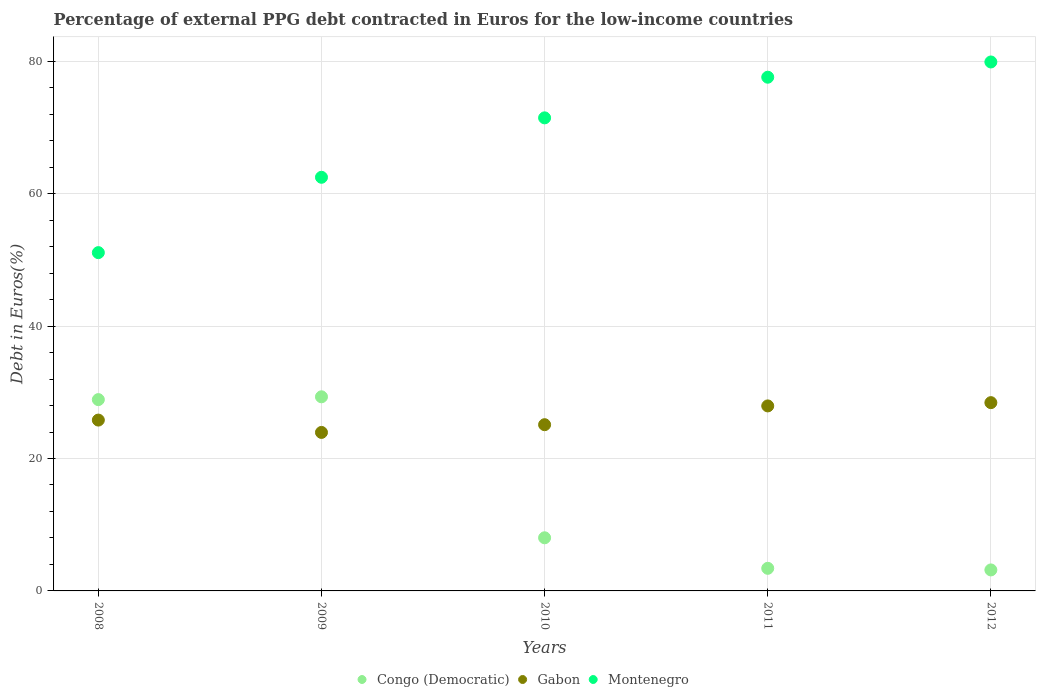Is the number of dotlines equal to the number of legend labels?
Give a very brief answer. Yes. What is the percentage of external PPG debt contracted in Euros in Montenegro in 2008?
Your answer should be very brief. 51.09. Across all years, what is the maximum percentage of external PPG debt contracted in Euros in Gabon?
Offer a very short reply. 28.43. Across all years, what is the minimum percentage of external PPG debt contracted in Euros in Montenegro?
Your answer should be compact. 51.09. In which year was the percentage of external PPG debt contracted in Euros in Montenegro maximum?
Offer a very short reply. 2012. In which year was the percentage of external PPG debt contracted in Euros in Gabon minimum?
Make the answer very short. 2009. What is the total percentage of external PPG debt contracted in Euros in Congo (Democratic) in the graph?
Keep it short and to the point. 72.82. What is the difference between the percentage of external PPG debt contracted in Euros in Gabon in 2008 and that in 2010?
Make the answer very short. 0.7. What is the difference between the percentage of external PPG debt contracted in Euros in Congo (Democratic) in 2009 and the percentage of external PPG debt contracted in Euros in Gabon in 2012?
Keep it short and to the point. 0.88. What is the average percentage of external PPG debt contracted in Euros in Gabon per year?
Offer a very short reply. 26.24. In the year 2011, what is the difference between the percentage of external PPG debt contracted in Euros in Gabon and percentage of external PPG debt contracted in Euros in Congo (Democratic)?
Your answer should be very brief. 24.53. What is the ratio of the percentage of external PPG debt contracted in Euros in Gabon in 2008 to that in 2009?
Your answer should be very brief. 1.08. Is the difference between the percentage of external PPG debt contracted in Euros in Gabon in 2009 and 2010 greater than the difference between the percentage of external PPG debt contracted in Euros in Congo (Democratic) in 2009 and 2010?
Offer a terse response. No. What is the difference between the highest and the second highest percentage of external PPG debt contracted in Euros in Congo (Democratic)?
Offer a very short reply. 0.42. What is the difference between the highest and the lowest percentage of external PPG debt contracted in Euros in Montenegro?
Provide a succinct answer. 28.8. Is the sum of the percentage of external PPG debt contracted in Euros in Congo (Democratic) in 2009 and 2011 greater than the maximum percentage of external PPG debt contracted in Euros in Gabon across all years?
Provide a short and direct response. Yes. Is the percentage of external PPG debt contracted in Euros in Gabon strictly less than the percentage of external PPG debt contracted in Euros in Montenegro over the years?
Offer a terse response. Yes. Are the values on the major ticks of Y-axis written in scientific E-notation?
Your answer should be compact. No. Does the graph contain any zero values?
Provide a succinct answer. No. Does the graph contain grids?
Provide a short and direct response. Yes. Where does the legend appear in the graph?
Keep it short and to the point. Bottom center. What is the title of the graph?
Provide a succinct answer. Percentage of external PPG debt contracted in Euros for the low-income countries. Does "Lesotho" appear as one of the legend labels in the graph?
Keep it short and to the point. No. What is the label or title of the Y-axis?
Offer a very short reply. Debt in Euros(%). What is the Debt in Euros(%) in Congo (Democratic) in 2008?
Provide a succinct answer. 28.89. What is the Debt in Euros(%) of Gabon in 2008?
Make the answer very short. 25.8. What is the Debt in Euros(%) in Montenegro in 2008?
Your answer should be very brief. 51.09. What is the Debt in Euros(%) in Congo (Democratic) in 2009?
Offer a very short reply. 29.32. What is the Debt in Euros(%) in Gabon in 2009?
Your answer should be compact. 23.94. What is the Debt in Euros(%) in Montenegro in 2009?
Give a very brief answer. 62.47. What is the Debt in Euros(%) of Congo (Democratic) in 2010?
Provide a succinct answer. 8.03. What is the Debt in Euros(%) in Gabon in 2010?
Provide a succinct answer. 25.1. What is the Debt in Euros(%) of Montenegro in 2010?
Provide a short and direct response. 71.45. What is the Debt in Euros(%) in Congo (Democratic) in 2011?
Your answer should be very brief. 3.41. What is the Debt in Euros(%) in Gabon in 2011?
Give a very brief answer. 27.94. What is the Debt in Euros(%) of Montenegro in 2011?
Make the answer very short. 77.58. What is the Debt in Euros(%) of Congo (Democratic) in 2012?
Offer a very short reply. 3.17. What is the Debt in Euros(%) in Gabon in 2012?
Keep it short and to the point. 28.43. What is the Debt in Euros(%) in Montenegro in 2012?
Ensure brevity in your answer.  79.89. Across all years, what is the maximum Debt in Euros(%) of Congo (Democratic)?
Make the answer very short. 29.32. Across all years, what is the maximum Debt in Euros(%) of Gabon?
Make the answer very short. 28.43. Across all years, what is the maximum Debt in Euros(%) of Montenegro?
Ensure brevity in your answer.  79.89. Across all years, what is the minimum Debt in Euros(%) of Congo (Democratic)?
Give a very brief answer. 3.17. Across all years, what is the minimum Debt in Euros(%) of Gabon?
Give a very brief answer. 23.94. Across all years, what is the minimum Debt in Euros(%) of Montenegro?
Make the answer very short. 51.09. What is the total Debt in Euros(%) in Congo (Democratic) in the graph?
Keep it short and to the point. 72.82. What is the total Debt in Euros(%) of Gabon in the graph?
Provide a short and direct response. 131.22. What is the total Debt in Euros(%) in Montenegro in the graph?
Your answer should be compact. 342.48. What is the difference between the Debt in Euros(%) of Congo (Democratic) in 2008 and that in 2009?
Keep it short and to the point. -0.42. What is the difference between the Debt in Euros(%) of Gabon in 2008 and that in 2009?
Keep it short and to the point. 1.86. What is the difference between the Debt in Euros(%) of Montenegro in 2008 and that in 2009?
Provide a short and direct response. -11.38. What is the difference between the Debt in Euros(%) of Congo (Democratic) in 2008 and that in 2010?
Keep it short and to the point. 20.87. What is the difference between the Debt in Euros(%) in Gabon in 2008 and that in 2010?
Your answer should be compact. 0.7. What is the difference between the Debt in Euros(%) of Montenegro in 2008 and that in 2010?
Offer a very short reply. -20.36. What is the difference between the Debt in Euros(%) in Congo (Democratic) in 2008 and that in 2011?
Your answer should be very brief. 25.48. What is the difference between the Debt in Euros(%) of Gabon in 2008 and that in 2011?
Provide a succinct answer. -2.14. What is the difference between the Debt in Euros(%) in Montenegro in 2008 and that in 2011?
Make the answer very short. -26.49. What is the difference between the Debt in Euros(%) in Congo (Democratic) in 2008 and that in 2012?
Provide a short and direct response. 25.72. What is the difference between the Debt in Euros(%) in Gabon in 2008 and that in 2012?
Your answer should be very brief. -2.63. What is the difference between the Debt in Euros(%) in Montenegro in 2008 and that in 2012?
Provide a short and direct response. -28.8. What is the difference between the Debt in Euros(%) of Congo (Democratic) in 2009 and that in 2010?
Make the answer very short. 21.29. What is the difference between the Debt in Euros(%) of Gabon in 2009 and that in 2010?
Provide a succinct answer. -1.17. What is the difference between the Debt in Euros(%) in Montenegro in 2009 and that in 2010?
Your answer should be compact. -8.98. What is the difference between the Debt in Euros(%) of Congo (Democratic) in 2009 and that in 2011?
Ensure brevity in your answer.  25.9. What is the difference between the Debt in Euros(%) of Gabon in 2009 and that in 2011?
Provide a short and direct response. -4. What is the difference between the Debt in Euros(%) in Montenegro in 2009 and that in 2011?
Your answer should be compact. -15.11. What is the difference between the Debt in Euros(%) in Congo (Democratic) in 2009 and that in 2012?
Give a very brief answer. 26.15. What is the difference between the Debt in Euros(%) of Gabon in 2009 and that in 2012?
Offer a terse response. -4.5. What is the difference between the Debt in Euros(%) of Montenegro in 2009 and that in 2012?
Provide a succinct answer. -17.41. What is the difference between the Debt in Euros(%) in Congo (Democratic) in 2010 and that in 2011?
Ensure brevity in your answer.  4.61. What is the difference between the Debt in Euros(%) of Gabon in 2010 and that in 2011?
Provide a succinct answer. -2.84. What is the difference between the Debt in Euros(%) in Montenegro in 2010 and that in 2011?
Provide a succinct answer. -6.14. What is the difference between the Debt in Euros(%) in Congo (Democratic) in 2010 and that in 2012?
Keep it short and to the point. 4.85. What is the difference between the Debt in Euros(%) of Gabon in 2010 and that in 2012?
Offer a very short reply. -3.33. What is the difference between the Debt in Euros(%) in Montenegro in 2010 and that in 2012?
Your answer should be very brief. -8.44. What is the difference between the Debt in Euros(%) of Congo (Democratic) in 2011 and that in 2012?
Offer a very short reply. 0.24. What is the difference between the Debt in Euros(%) of Gabon in 2011 and that in 2012?
Your answer should be compact. -0.49. What is the difference between the Debt in Euros(%) of Montenegro in 2011 and that in 2012?
Offer a very short reply. -2.3. What is the difference between the Debt in Euros(%) in Congo (Democratic) in 2008 and the Debt in Euros(%) in Gabon in 2009?
Give a very brief answer. 4.96. What is the difference between the Debt in Euros(%) of Congo (Democratic) in 2008 and the Debt in Euros(%) of Montenegro in 2009?
Make the answer very short. -33.58. What is the difference between the Debt in Euros(%) of Gabon in 2008 and the Debt in Euros(%) of Montenegro in 2009?
Keep it short and to the point. -36.67. What is the difference between the Debt in Euros(%) of Congo (Democratic) in 2008 and the Debt in Euros(%) of Gabon in 2010?
Offer a terse response. 3.79. What is the difference between the Debt in Euros(%) in Congo (Democratic) in 2008 and the Debt in Euros(%) in Montenegro in 2010?
Provide a short and direct response. -42.55. What is the difference between the Debt in Euros(%) of Gabon in 2008 and the Debt in Euros(%) of Montenegro in 2010?
Your answer should be compact. -45.64. What is the difference between the Debt in Euros(%) in Congo (Democratic) in 2008 and the Debt in Euros(%) in Gabon in 2011?
Provide a short and direct response. 0.95. What is the difference between the Debt in Euros(%) of Congo (Democratic) in 2008 and the Debt in Euros(%) of Montenegro in 2011?
Offer a terse response. -48.69. What is the difference between the Debt in Euros(%) of Gabon in 2008 and the Debt in Euros(%) of Montenegro in 2011?
Your answer should be compact. -51.78. What is the difference between the Debt in Euros(%) in Congo (Democratic) in 2008 and the Debt in Euros(%) in Gabon in 2012?
Provide a succinct answer. 0.46. What is the difference between the Debt in Euros(%) of Congo (Democratic) in 2008 and the Debt in Euros(%) of Montenegro in 2012?
Keep it short and to the point. -50.99. What is the difference between the Debt in Euros(%) of Gabon in 2008 and the Debt in Euros(%) of Montenegro in 2012?
Keep it short and to the point. -54.08. What is the difference between the Debt in Euros(%) of Congo (Democratic) in 2009 and the Debt in Euros(%) of Gabon in 2010?
Provide a short and direct response. 4.21. What is the difference between the Debt in Euros(%) of Congo (Democratic) in 2009 and the Debt in Euros(%) of Montenegro in 2010?
Give a very brief answer. -42.13. What is the difference between the Debt in Euros(%) of Gabon in 2009 and the Debt in Euros(%) of Montenegro in 2010?
Give a very brief answer. -47.51. What is the difference between the Debt in Euros(%) of Congo (Democratic) in 2009 and the Debt in Euros(%) of Gabon in 2011?
Ensure brevity in your answer.  1.38. What is the difference between the Debt in Euros(%) of Congo (Democratic) in 2009 and the Debt in Euros(%) of Montenegro in 2011?
Your answer should be very brief. -48.27. What is the difference between the Debt in Euros(%) of Gabon in 2009 and the Debt in Euros(%) of Montenegro in 2011?
Your answer should be compact. -53.65. What is the difference between the Debt in Euros(%) in Congo (Democratic) in 2009 and the Debt in Euros(%) in Gabon in 2012?
Your answer should be very brief. 0.88. What is the difference between the Debt in Euros(%) in Congo (Democratic) in 2009 and the Debt in Euros(%) in Montenegro in 2012?
Offer a very short reply. -50.57. What is the difference between the Debt in Euros(%) in Gabon in 2009 and the Debt in Euros(%) in Montenegro in 2012?
Your answer should be compact. -55.95. What is the difference between the Debt in Euros(%) of Congo (Democratic) in 2010 and the Debt in Euros(%) of Gabon in 2011?
Give a very brief answer. -19.92. What is the difference between the Debt in Euros(%) in Congo (Democratic) in 2010 and the Debt in Euros(%) in Montenegro in 2011?
Your answer should be compact. -69.56. What is the difference between the Debt in Euros(%) in Gabon in 2010 and the Debt in Euros(%) in Montenegro in 2011?
Ensure brevity in your answer.  -52.48. What is the difference between the Debt in Euros(%) of Congo (Democratic) in 2010 and the Debt in Euros(%) of Gabon in 2012?
Give a very brief answer. -20.41. What is the difference between the Debt in Euros(%) of Congo (Democratic) in 2010 and the Debt in Euros(%) of Montenegro in 2012?
Give a very brief answer. -71.86. What is the difference between the Debt in Euros(%) in Gabon in 2010 and the Debt in Euros(%) in Montenegro in 2012?
Offer a terse response. -54.78. What is the difference between the Debt in Euros(%) of Congo (Democratic) in 2011 and the Debt in Euros(%) of Gabon in 2012?
Your response must be concise. -25.02. What is the difference between the Debt in Euros(%) in Congo (Democratic) in 2011 and the Debt in Euros(%) in Montenegro in 2012?
Offer a very short reply. -76.47. What is the difference between the Debt in Euros(%) in Gabon in 2011 and the Debt in Euros(%) in Montenegro in 2012?
Give a very brief answer. -51.94. What is the average Debt in Euros(%) in Congo (Democratic) per year?
Make the answer very short. 14.56. What is the average Debt in Euros(%) in Gabon per year?
Keep it short and to the point. 26.24. What is the average Debt in Euros(%) of Montenegro per year?
Make the answer very short. 68.5. In the year 2008, what is the difference between the Debt in Euros(%) of Congo (Democratic) and Debt in Euros(%) of Gabon?
Offer a very short reply. 3.09. In the year 2008, what is the difference between the Debt in Euros(%) in Congo (Democratic) and Debt in Euros(%) in Montenegro?
Offer a very short reply. -22.2. In the year 2008, what is the difference between the Debt in Euros(%) of Gabon and Debt in Euros(%) of Montenegro?
Your answer should be very brief. -25.29. In the year 2009, what is the difference between the Debt in Euros(%) in Congo (Democratic) and Debt in Euros(%) in Gabon?
Your response must be concise. 5.38. In the year 2009, what is the difference between the Debt in Euros(%) in Congo (Democratic) and Debt in Euros(%) in Montenegro?
Offer a terse response. -33.15. In the year 2009, what is the difference between the Debt in Euros(%) of Gabon and Debt in Euros(%) of Montenegro?
Your response must be concise. -38.53. In the year 2010, what is the difference between the Debt in Euros(%) of Congo (Democratic) and Debt in Euros(%) of Gabon?
Offer a terse response. -17.08. In the year 2010, what is the difference between the Debt in Euros(%) of Congo (Democratic) and Debt in Euros(%) of Montenegro?
Offer a very short reply. -63.42. In the year 2010, what is the difference between the Debt in Euros(%) in Gabon and Debt in Euros(%) in Montenegro?
Offer a very short reply. -46.34. In the year 2011, what is the difference between the Debt in Euros(%) of Congo (Democratic) and Debt in Euros(%) of Gabon?
Your response must be concise. -24.53. In the year 2011, what is the difference between the Debt in Euros(%) of Congo (Democratic) and Debt in Euros(%) of Montenegro?
Ensure brevity in your answer.  -74.17. In the year 2011, what is the difference between the Debt in Euros(%) in Gabon and Debt in Euros(%) in Montenegro?
Your answer should be very brief. -49.64. In the year 2012, what is the difference between the Debt in Euros(%) in Congo (Democratic) and Debt in Euros(%) in Gabon?
Offer a terse response. -25.26. In the year 2012, what is the difference between the Debt in Euros(%) of Congo (Democratic) and Debt in Euros(%) of Montenegro?
Provide a succinct answer. -76.71. In the year 2012, what is the difference between the Debt in Euros(%) in Gabon and Debt in Euros(%) in Montenegro?
Your answer should be compact. -51.45. What is the ratio of the Debt in Euros(%) of Congo (Democratic) in 2008 to that in 2009?
Your response must be concise. 0.99. What is the ratio of the Debt in Euros(%) of Gabon in 2008 to that in 2009?
Make the answer very short. 1.08. What is the ratio of the Debt in Euros(%) in Montenegro in 2008 to that in 2009?
Provide a succinct answer. 0.82. What is the ratio of the Debt in Euros(%) in Congo (Democratic) in 2008 to that in 2010?
Your answer should be compact. 3.6. What is the ratio of the Debt in Euros(%) in Gabon in 2008 to that in 2010?
Offer a very short reply. 1.03. What is the ratio of the Debt in Euros(%) of Montenegro in 2008 to that in 2010?
Provide a short and direct response. 0.72. What is the ratio of the Debt in Euros(%) in Congo (Democratic) in 2008 to that in 2011?
Make the answer very short. 8.46. What is the ratio of the Debt in Euros(%) in Gabon in 2008 to that in 2011?
Your answer should be compact. 0.92. What is the ratio of the Debt in Euros(%) in Montenegro in 2008 to that in 2011?
Make the answer very short. 0.66. What is the ratio of the Debt in Euros(%) in Congo (Democratic) in 2008 to that in 2012?
Provide a short and direct response. 9.11. What is the ratio of the Debt in Euros(%) of Gabon in 2008 to that in 2012?
Keep it short and to the point. 0.91. What is the ratio of the Debt in Euros(%) in Montenegro in 2008 to that in 2012?
Give a very brief answer. 0.64. What is the ratio of the Debt in Euros(%) in Congo (Democratic) in 2009 to that in 2010?
Provide a short and direct response. 3.65. What is the ratio of the Debt in Euros(%) in Gabon in 2009 to that in 2010?
Provide a short and direct response. 0.95. What is the ratio of the Debt in Euros(%) of Montenegro in 2009 to that in 2010?
Your answer should be compact. 0.87. What is the ratio of the Debt in Euros(%) of Congo (Democratic) in 2009 to that in 2011?
Keep it short and to the point. 8.59. What is the ratio of the Debt in Euros(%) in Gabon in 2009 to that in 2011?
Make the answer very short. 0.86. What is the ratio of the Debt in Euros(%) of Montenegro in 2009 to that in 2011?
Your answer should be very brief. 0.81. What is the ratio of the Debt in Euros(%) in Congo (Democratic) in 2009 to that in 2012?
Ensure brevity in your answer.  9.24. What is the ratio of the Debt in Euros(%) in Gabon in 2009 to that in 2012?
Your answer should be very brief. 0.84. What is the ratio of the Debt in Euros(%) of Montenegro in 2009 to that in 2012?
Give a very brief answer. 0.78. What is the ratio of the Debt in Euros(%) in Congo (Democratic) in 2010 to that in 2011?
Your answer should be compact. 2.35. What is the ratio of the Debt in Euros(%) of Gabon in 2010 to that in 2011?
Offer a very short reply. 0.9. What is the ratio of the Debt in Euros(%) in Montenegro in 2010 to that in 2011?
Your response must be concise. 0.92. What is the ratio of the Debt in Euros(%) of Congo (Democratic) in 2010 to that in 2012?
Your answer should be compact. 2.53. What is the ratio of the Debt in Euros(%) of Gabon in 2010 to that in 2012?
Your answer should be very brief. 0.88. What is the ratio of the Debt in Euros(%) of Montenegro in 2010 to that in 2012?
Your response must be concise. 0.89. What is the ratio of the Debt in Euros(%) of Congo (Democratic) in 2011 to that in 2012?
Give a very brief answer. 1.08. What is the ratio of the Debt in Euros(%) of Gabon in 2011 to that in 2012?
Your answer should be very brief. 0.98. What is the ratio of the Debt in Euros(%) in Montenegro in 2011 to that in 2012?
Keep it short and to the point. 0.97. What is the difference between the highest and the second highest Debt in Euros(%) in Congo (Democratic)?
Your answer should be compact. 0.42. What is the difference between the highest and the second highest Debt in Euros(%) of Gabon?
Your response must be concise. 0.49. What is the difference between the highest and the second highest Debt in Euros(%) of Montenegro?
Keep it short and to the point. 2.3. What is the difference between the highest and the lowest Debt in Euros(%) in Congo (Democratic)?
Offer a terse response. 26.15. What is the difference between the highest and the lowest Debt in Euros(%) in Gabon?
Offer a terse response. 4.5. What is the difference between the highest and the lowest Debt in Euros(%) of Montenegro?
Provide a succinct answer. 28.8. 